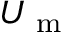<formula> <loc_0><loc_0><loc_500><loc_500>U _ { m }</formula> 